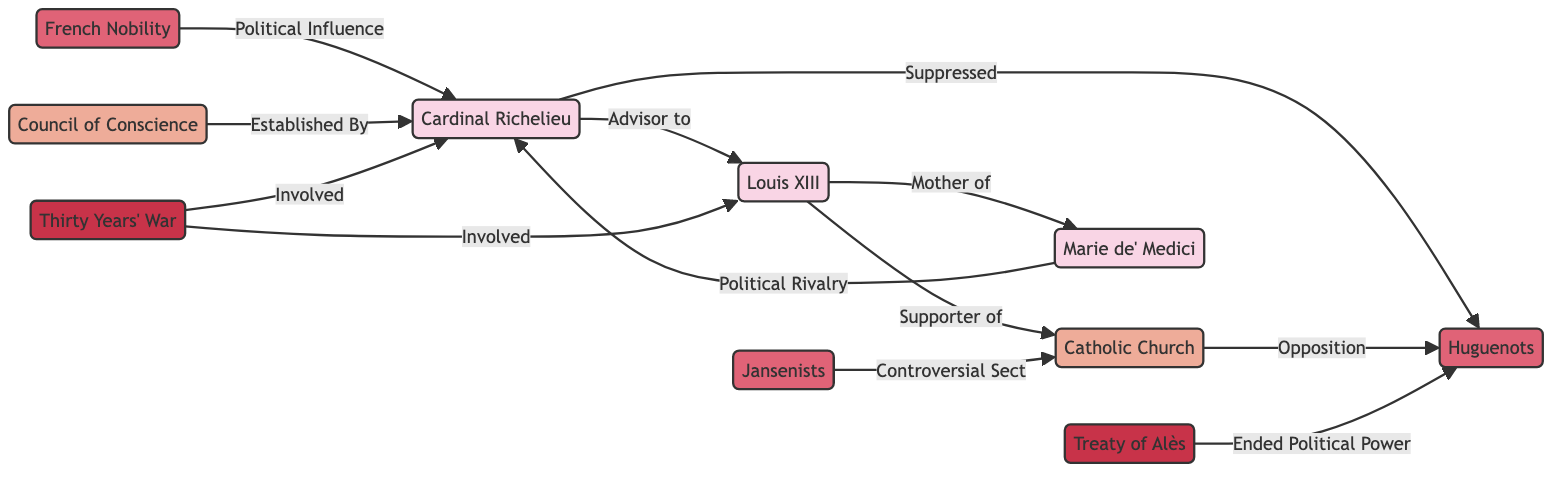What's the total number of nodes in the diagram? By counting the distinct elements represented in the diagram, we find there are 10 nodes in total: 5 persons, 3 groups, 2 institutions, and 2 events.
Answer: 10 Who is the advisor to Louis XIII? The diagram clearly shows a direct relationship labeled "Advisor to" connecting Cardinal Richelieu and Louis XIII, indicating that Cardinal Richelieu is the advisor.
Answer: Cardinal Richelieu What group was suppressed by Cardinal Richelieu? The relationship labeled "Suppressed" indicates that the Huguenots were the group suppressed by Cardinal Richelieu.
Answer: Huguenots Which event ended the political power of the Huguenots? The Treaty of Alès is associated with the phrase "Ended Political Power", showing that this event marked the end of political power for the Huguenots.
Answer: Treaty of Alès How many groups are mentioned in the diagram? By identifying the elements labeled as groups, we see that there are three: Huguenots, French Nobility, and Jansenists. Therefore, the total number of groups is three.
Answer: 3 What is the relationship between the Catholic Church and the Huguenots? The diagram indicates an opposition relationship between the Catholic Church and the Huguenots, demonstrating a direct conflict in their stance.
Answer: Opposition Who is the political rival of Cardinal Richelieu? The relationship labeled "Political Rivalry" shows that Marie de' Medici is identified as the political rival to Cardinal Richelieu.
Answer: Marie de' Medici Which institution was established by Cardinal Richelieu? A connection labeled "Established By" links Cardinal Richelieu to the Council of Conscience, indicating that this institution was established through his influence.
Answer: Council of Conscience Involved in which major conflict are both Louis XIII and Cardinal Richelieu? The Thirty Years' War is mentioned with both Louis XIII and Cardinal Richelieu being identified as involved, highlighting their roles in this major conflict.
Answer: Thirty Years' War What is the relationship between the Catholic Church and Jansenists? The diagram describes the Jansenists as a "Controversial Sect" in relation to the Catholic Church, suggesting potential theological or political discord.
Answer: Controversial Sect 